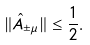Convert formula to latex. <formula><loc_0><loc_0><loc_500><loc_500>\| \hat { A } _ { \pm \mu } \| \leq \frac { 1 } { 2 } .</formula> 